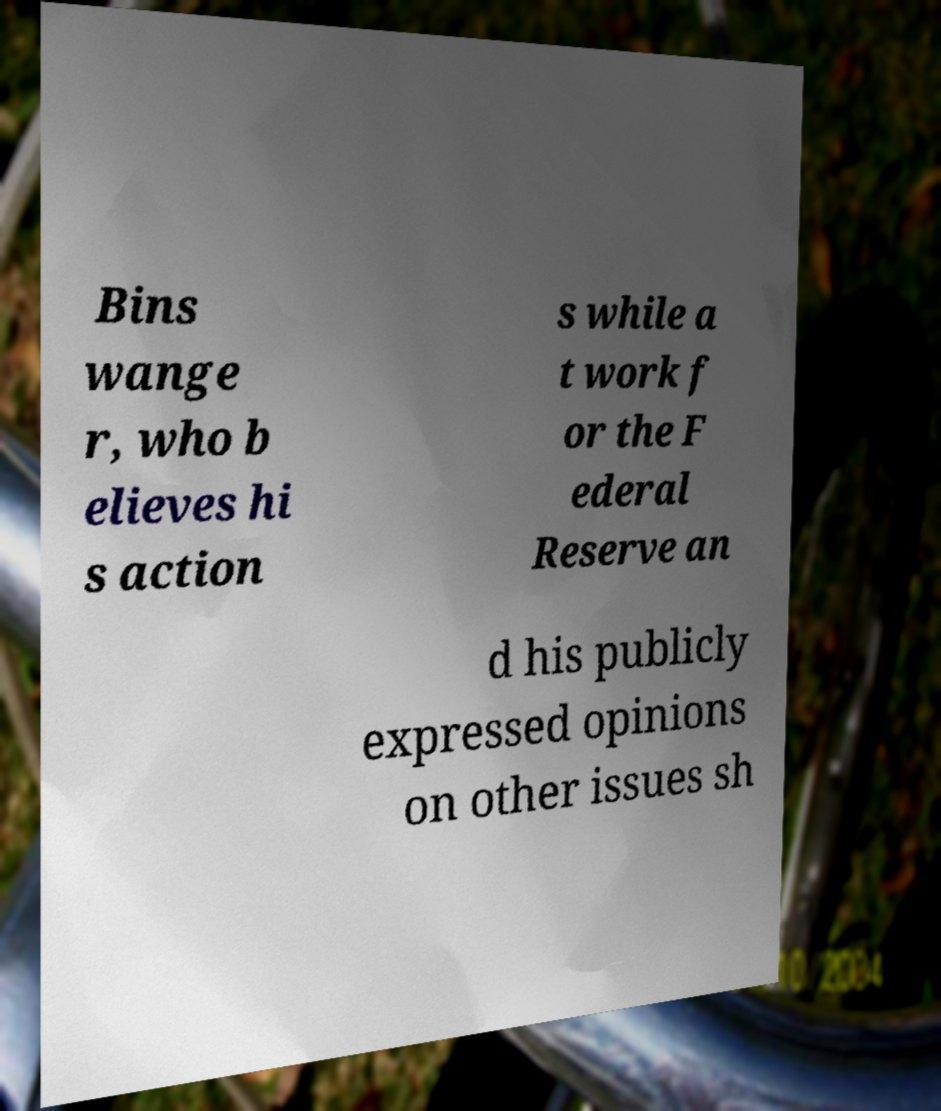There's text embedded in this image that I need extracted. Can you transcribe it verbatim? Bins wange r, who b elieves hi s action s while a t work f or the F ederal Reserve an d his publicly expressed opinions on other issues sh 